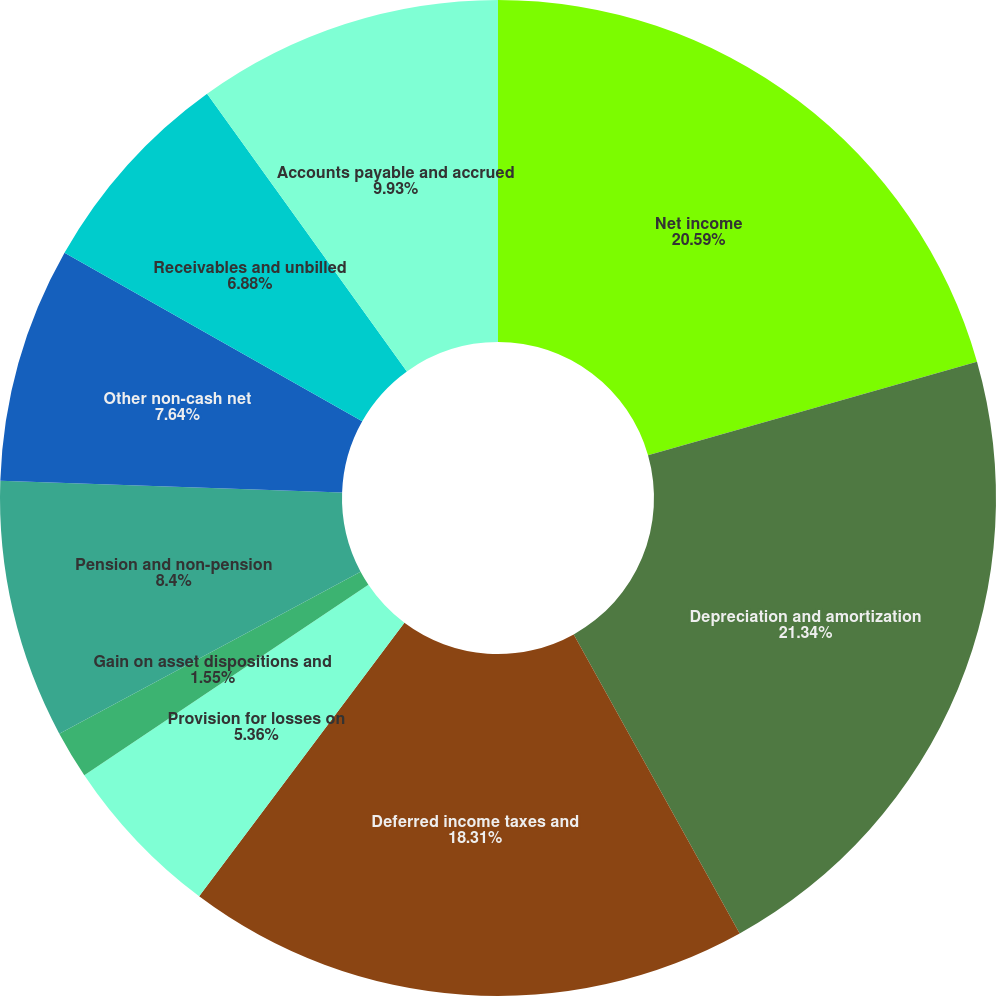Convert chart. <chart><loc_0><loc_0><loc_500><loc_500><pie_chart><fcel>Net income<fcel>Depreciation and amortization<fcel>Deferred income taxes and<fcel>Provision for losses on<fcel>Gain on asset dispositions and<fcel>Pension and non-pension<fcel>Other non-cash net<fcel>Receivables and unbilled<fcel>Accounts payable and accrued<nl><fcel>20.59%<fcel>21.35%<fcel>18.31%<fcel>5.36%<fcel>1.55%<fcel>8.4%<fcel>7.64%<fcel>6.88%<fcel>9.93%<nl></chart> 